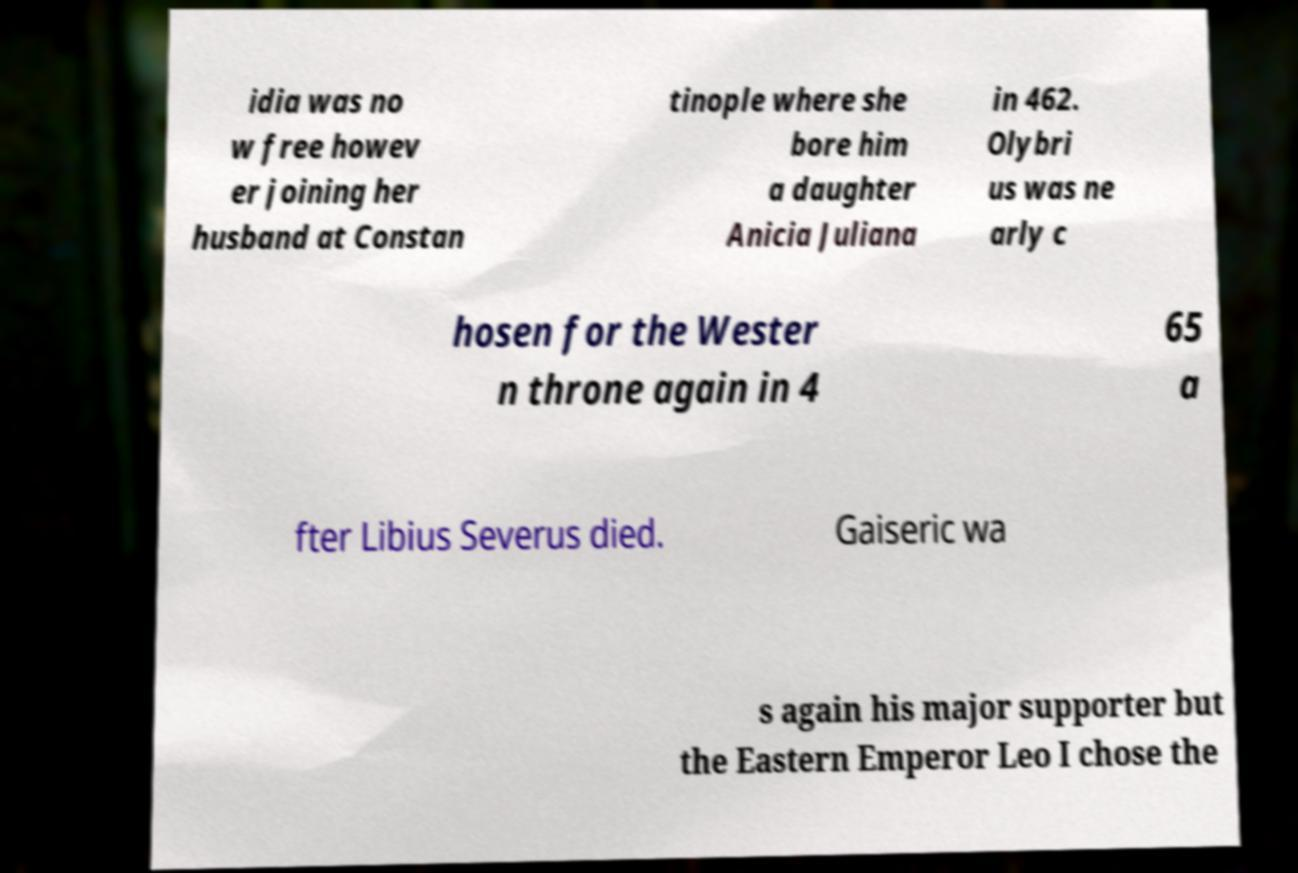Can you accurately transcribe the text from the provided image for me? idia was no w free howev er joining her husband at Constan tinople where she bore him a daughter Anicia Juliana in 462. Olybri us was ne arly c hosen for the Wester n throne again in 4 65 a fter Libius Severus died. Gaiseric wa s again his major supporter but the Eastern Emperor Leo I chose the 